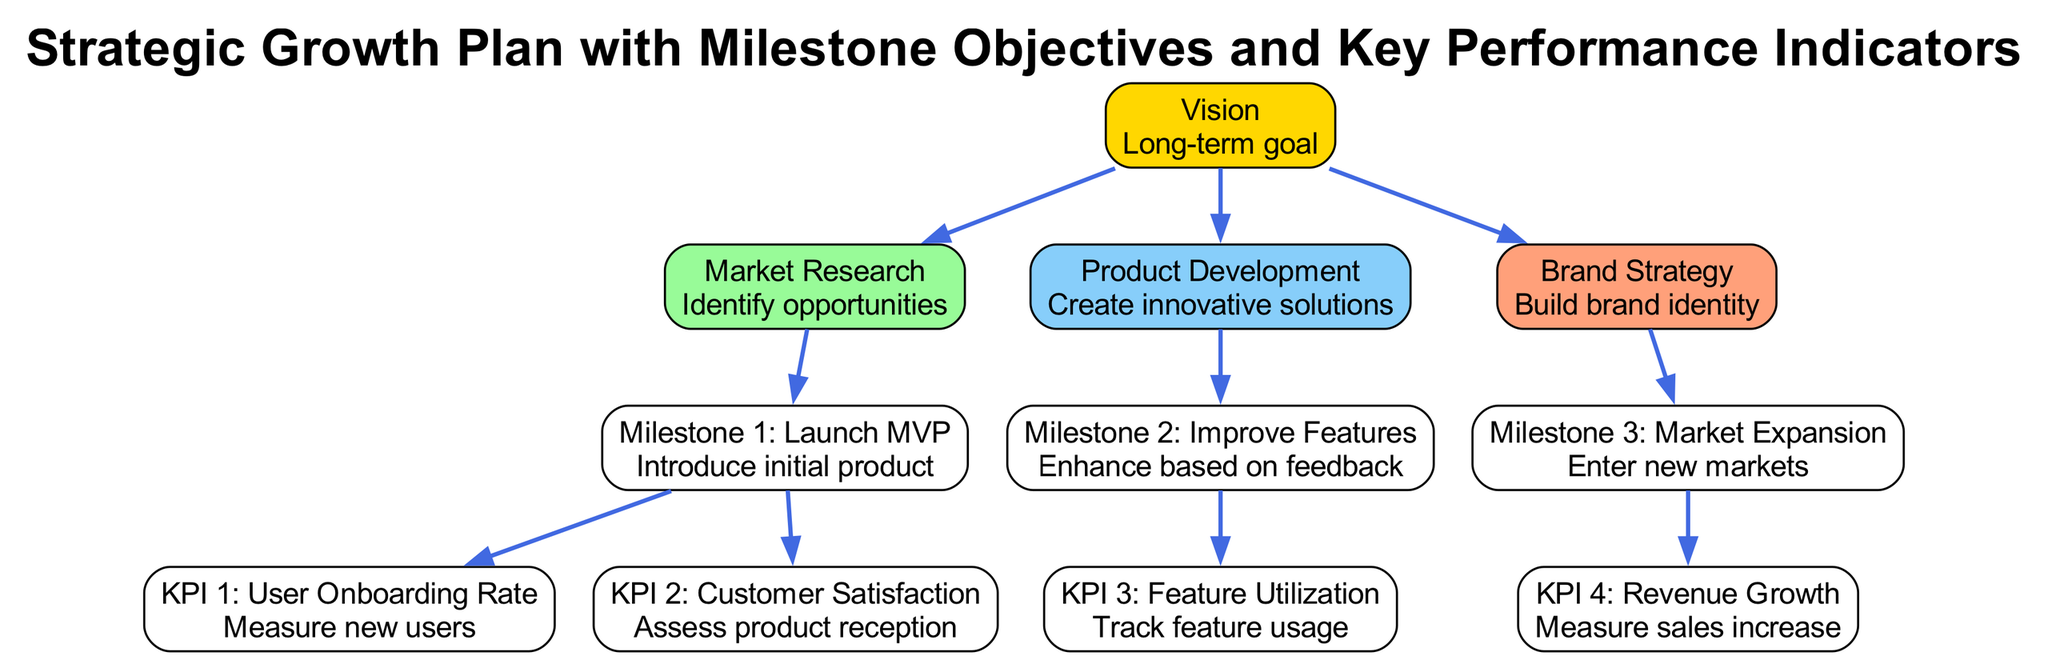What is the ultimate goal represented in the diagram? The ultimate goal, represented by the top box labeled "Vision," indicates the long-term goal for the strategic growth plan.
Answer: Vision How many milestone objectives are listed in the diagram? The diagram contains three milestones labeled "Milestone 1: Launch MVP," "Milestone 2: Improve Features," and "Milestone 3: Market Expansion." This totals three milestones.
Answer: 3 What is the description associated with "Market Research"? The description for "Market Research" states "Identify opportunities," which specifies its purpose in the growth strategy.
Answer: Identify opportunities Which KPI measures the increase in sales? The KPI labeled "KPI 4: Revenue Growth" specifically addresses the measurement of sales increases.
Answer: KPI 4: Revenue Growth What is Milestone 1 called? Milestone 1 is labeled "Milestone 1: Launch MVP," indicating the initial step in the product introduction process.
Answer: Milestone 1: Launch MVP How is "Feature Utilization" evaluated in the strategic plan? "Feature Utilization" is evaluated through "KPI 3," which tracks the usage of various features implemented in the product based on user interaction and feedback.
Answer: KPI 3: Feature Utilization Which two elements connect to "Milestone 1"? "Milestone 1: Launch MVP" connects to two KPIs: "KPI 1: User Onboarding Rate" and "KPI 2: Customer Satisfaction," reflecting the metrics related to this milestone.
Answer: KPI 1: User Onboarding Rate, KPI 2: Customer Satisfaction What is the relationship between "Brand Strategy" and its milestone? "Brand Strategy" links directly to "Milestone 3: Market Expansion," indicating that creating a brand identity leads into the strategic goal of expanding into new markets.
Answer: Milestone 3: Market Expansion What color represents "Product Development" in the diagram? "Product Development" is depicted in a light sky blue color (#87CEFA), distinguishing it visually from other elements in the growth plan.
Answer: Light sky blue 